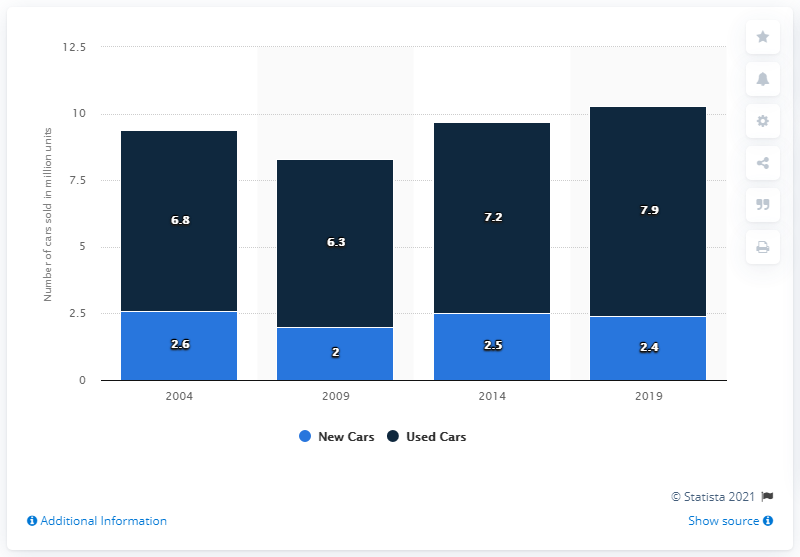Point out several critical features in this image. The difference between the highest and lowest dark blue bar in the graph is 1.6 times. The highest market volume of used cars sold in the United Kingdom between 2004 and 2019 was 7.9 million units sold. 